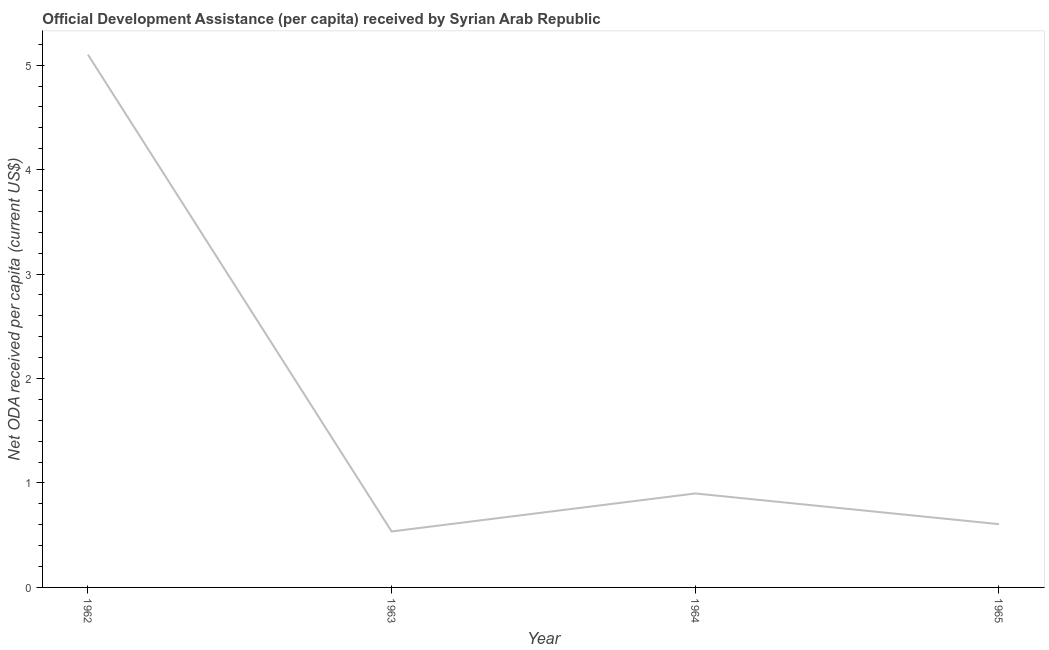What is the net oda received per capita in 1965?
Keep it short and to the point. 0.61. Across all years, what is the maximum net oda received per capita?
Give a very brief answer. 5.1. Across all years, what is the minimum net oda received per capita?
Provide a short and direct response. 0.54. In which year was the net oda received per capita minimum?
Your answer should be very brief. 1963. What is the sum of the net oda received per capita?
Your response must be concise. 7.14. What is the difference between the net oda received per capita in 1964 and 1965?
Your response must be concise. 0.29. What is the average net oda received per capita per year?
Give a very brief answer. 1.79. What is the median net oda received per capita?
Ensure brevity in your answer.  0.75. In how many years, is the net oda received per capita greater than 2 US$?
Make the answer very short. 1. What is the ratio of the net oda received per capita in 1963 to that in 1964?
Your response must be concise. 0.6. Is the difference between the net oda received per capita in 1963 and 1964 greater than the difference between any two years?
Your response must be concise. No. What is the difference between the highest and the second highest net oda received per capita?
Your answer should be compact. 4.2. What is the difference between the highest and the lowest net oda received per capita?
Give a very brief answer. 4.56. In how many years, is the net oda received per capita greater than the average net oda received per capita taken over all years?
Provide a short and direct response. 1. How many years are there in the graph?
Offer a terse response. 4. What is the difference between two consecutive major ticks on the Y-axis?
Offer a very short reply. 1. What is the title of the graph?
Your answer should be very brief. Official Development Assistance (per capita) received by Syrian Arab Republic. What is the label or title of the X-axis?
Your response must be concise. Year. What is the label or title of the Y-axis?
Offer a terse response. Net ODA received per capita (current US$). What is the Net ODA received per capita (current US$) of 1962?
Offer a terse response. 5.1. What is the Net ODA received per capita (current US$) in 1963?
Offer a terse response. 0.54. What is the Net ODA received per capita (current US$) of 1964?
Offer a terse response. 0.9. What is the Net ODA received per capita (current US$) of 1965?
Make the answer very short. 0.61. What is the difference between the Net ODA received per capita (current US$) in 1962 and 1963?
Your response must be concise. 4.56. What is the difference between the Net ODA received per capita (current US$) in 1962 and 1964?
Ensure brevity in your answer.  4.2. What is the difference between the Net ODA received per capita (current US$) in 1962 and 1965?
Offer a terse response. 4.49. What is the difference between the Net ODA received per capita (current US$) in 1963 and 1964?
Offer a very short reply. -0.36. What is the difference between the Net ODA received per capita (current US$) in 1963 and 1965?
Offer a very short reply. -0.07. What is the difference between the Net ODA received per capita (current US$) in 1964 and 1965?
Your answer should be compact. 0.29. What is the ratio of the Net ODA received per capita (current US$) in 1962 to that in 1963?
Your response must be concise. 9.52. What is the ratio of the Net ODA received per capita (current US$) in 1962 to that in 1964?
Provide a succinct answer. 5.67. What is the ratio of the Net ODA received per capita (current US$) in 1962 to that in 1965?
Your response must be concise. 8.42. What is the ratio of the Net ODA received per capita (current US$) in 1963 to that in 1964?
Ensure brevity in your answer.  0.6. What is the ratio of the Net ODA received per capita (current US$) in 1963 to that in 1965?
Keep it short and to the point. 0.89. What is the ratio of the Net ODA received per capita (current US$) in 1964 to that in 1965?
Your answer should be compact. 1.49. 